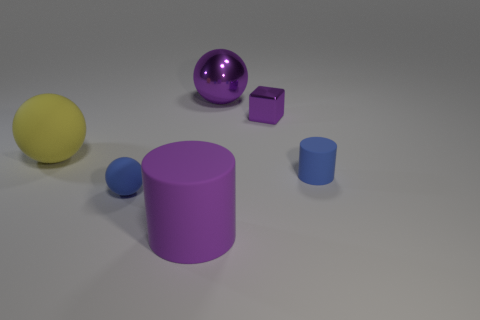Is there anything else that is the same color as the shiny ball?
Give a very brief answer. Yes. Are there any purple matte objects in front of the large matte object in front of the blue rubber sphere that is left of the large purple metal thing?
Your response must be concise. No. Is the shape of the blue thing on the left side of the large cylinder the same as  the large purple metallic thing?
Your answer should be very brief. Yes. Are there fewer cubes that are on the left side of the tiny metal object than purple objects to the right of the big purple shiny object?
Offer a terse response. Yes. What is the big purple sphere made of?
Provide a succinct answer. Metal. Does the small ball have the same color as the large matte object that is to the right of the large yellow object?
Provide a succinct answer. No. What number of small rubber cylinders are in front of the big rubber ball?
Provide a succinct answer. 1. Is the number of small matte objects on the left side of the purple metallic ball less than the number of yellow cubes?
Your response must be concise. No. What color is the small metal cube?
Your answer should be very brief. Purple. There is a cylinder that is on the right side of the small purple cube; is its color the same as the large rubber ball?
Provide a short and direct response. No. 